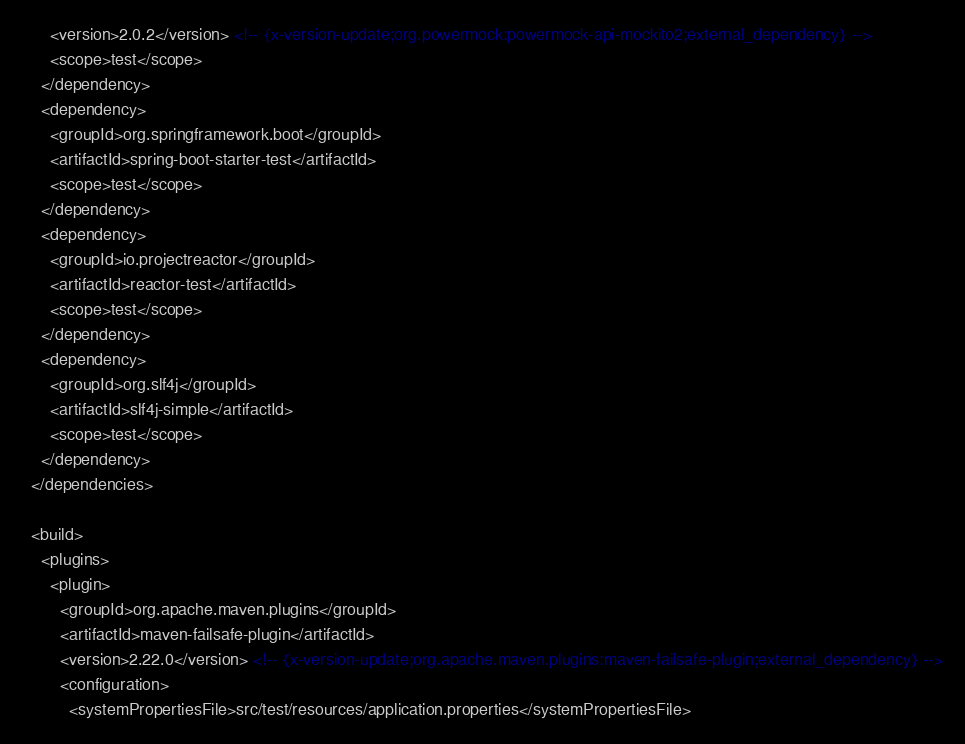<code> <loc_0><loc_0><loc_500><loc_500><_XML_>      <version>2.0.2</version> <!-- {x-version-update;org.powermock:powermock-api-mockito2;external_dependency} -->
      <scope>test</scope>
    </dependency>
    <dependency>
      <groupId>org.springframework.boot</groupId>
      <artifactId>spring-boot-starter-test</artifactId>
      <scope>test</scope>
    </dependency>
    <dependency>
      <groupId>io.projectreactor</groupId>
      <artifactId>reactor-test</artifactId>
      <scope>test</scope>
    </dependency>
    <dependency>
      <groupId>org.slf4j</groupId>
      <artifactId>slf4j-simple</artifactId>
      <scope>test</scope>
    </dependency>
  </dependencies>

  <build>
    <plugins>
      <plugin>
        <groupId>org.apache.maven.plugins</groupId>
        <artifactId>maven-failsafe-plugin</artifactId>
        <version>2.22.0</version> <!-- {x-version-update;org.apache.maven.plugins:maven-failsafe-plugin;external_dependency} -->
        <configuration>
          <systemPropertiesFile>src/test/resources/application.properties</systemPropertiesFile></code> 